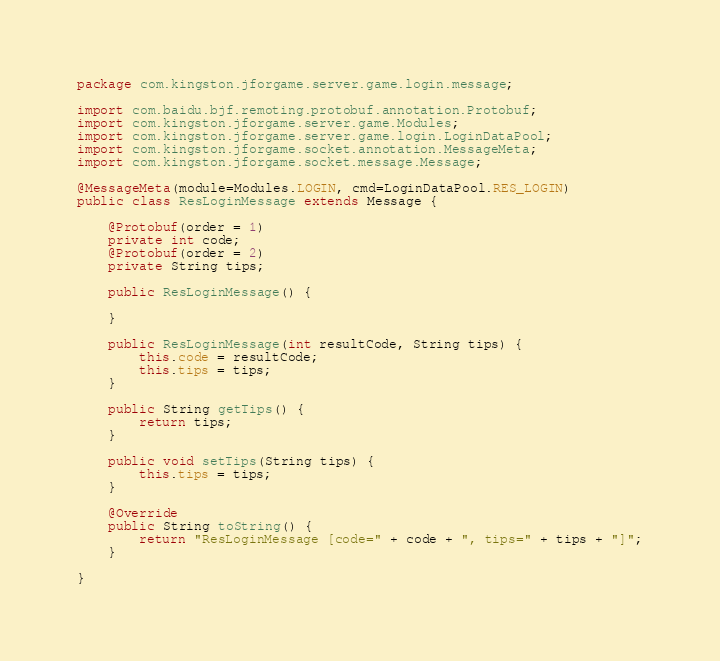<code> <loc_0><loc_0><loc_500><loc_500><_Java_>package com.kingston.jforgame.server.game.login.message;

import com.baidu.bjf.remoting.protobuf.annotation.Protobuf;
import com.kingston.jforgame.server.game.Modules;
import com.kingston.jforgame.server.game.login.LoginDataPool;
import com.kingston.jforgame.socket.annotation.MessageMeta;
import com.kingston.jforgame.socket.message.Message;

@MessageMeta(module=Modules.LOGIN, cmd=LoginDataPool.RES_LOGIN)
public class ResLoginMessage extends Message {

	@Protobuf(order = 1)
	private int code;
	@Protobuf(order = 2)
	private String tips;
	
	public ResLoginMessage() {
		
	}
	
	public ResLoginMessage(int resultCode, String tips) {
		this.code = resultCode;
		this.tips = tips;
	}

	public String getTips() {
		return tips;
	}

	public void setTips(String tips) {
		this.tips = tips;
	}

	@Override
	public String toString() {
		return "ResLoginMessage [code=" + code + ", tips=" + tips + "]";
	}
	
}
</code> 